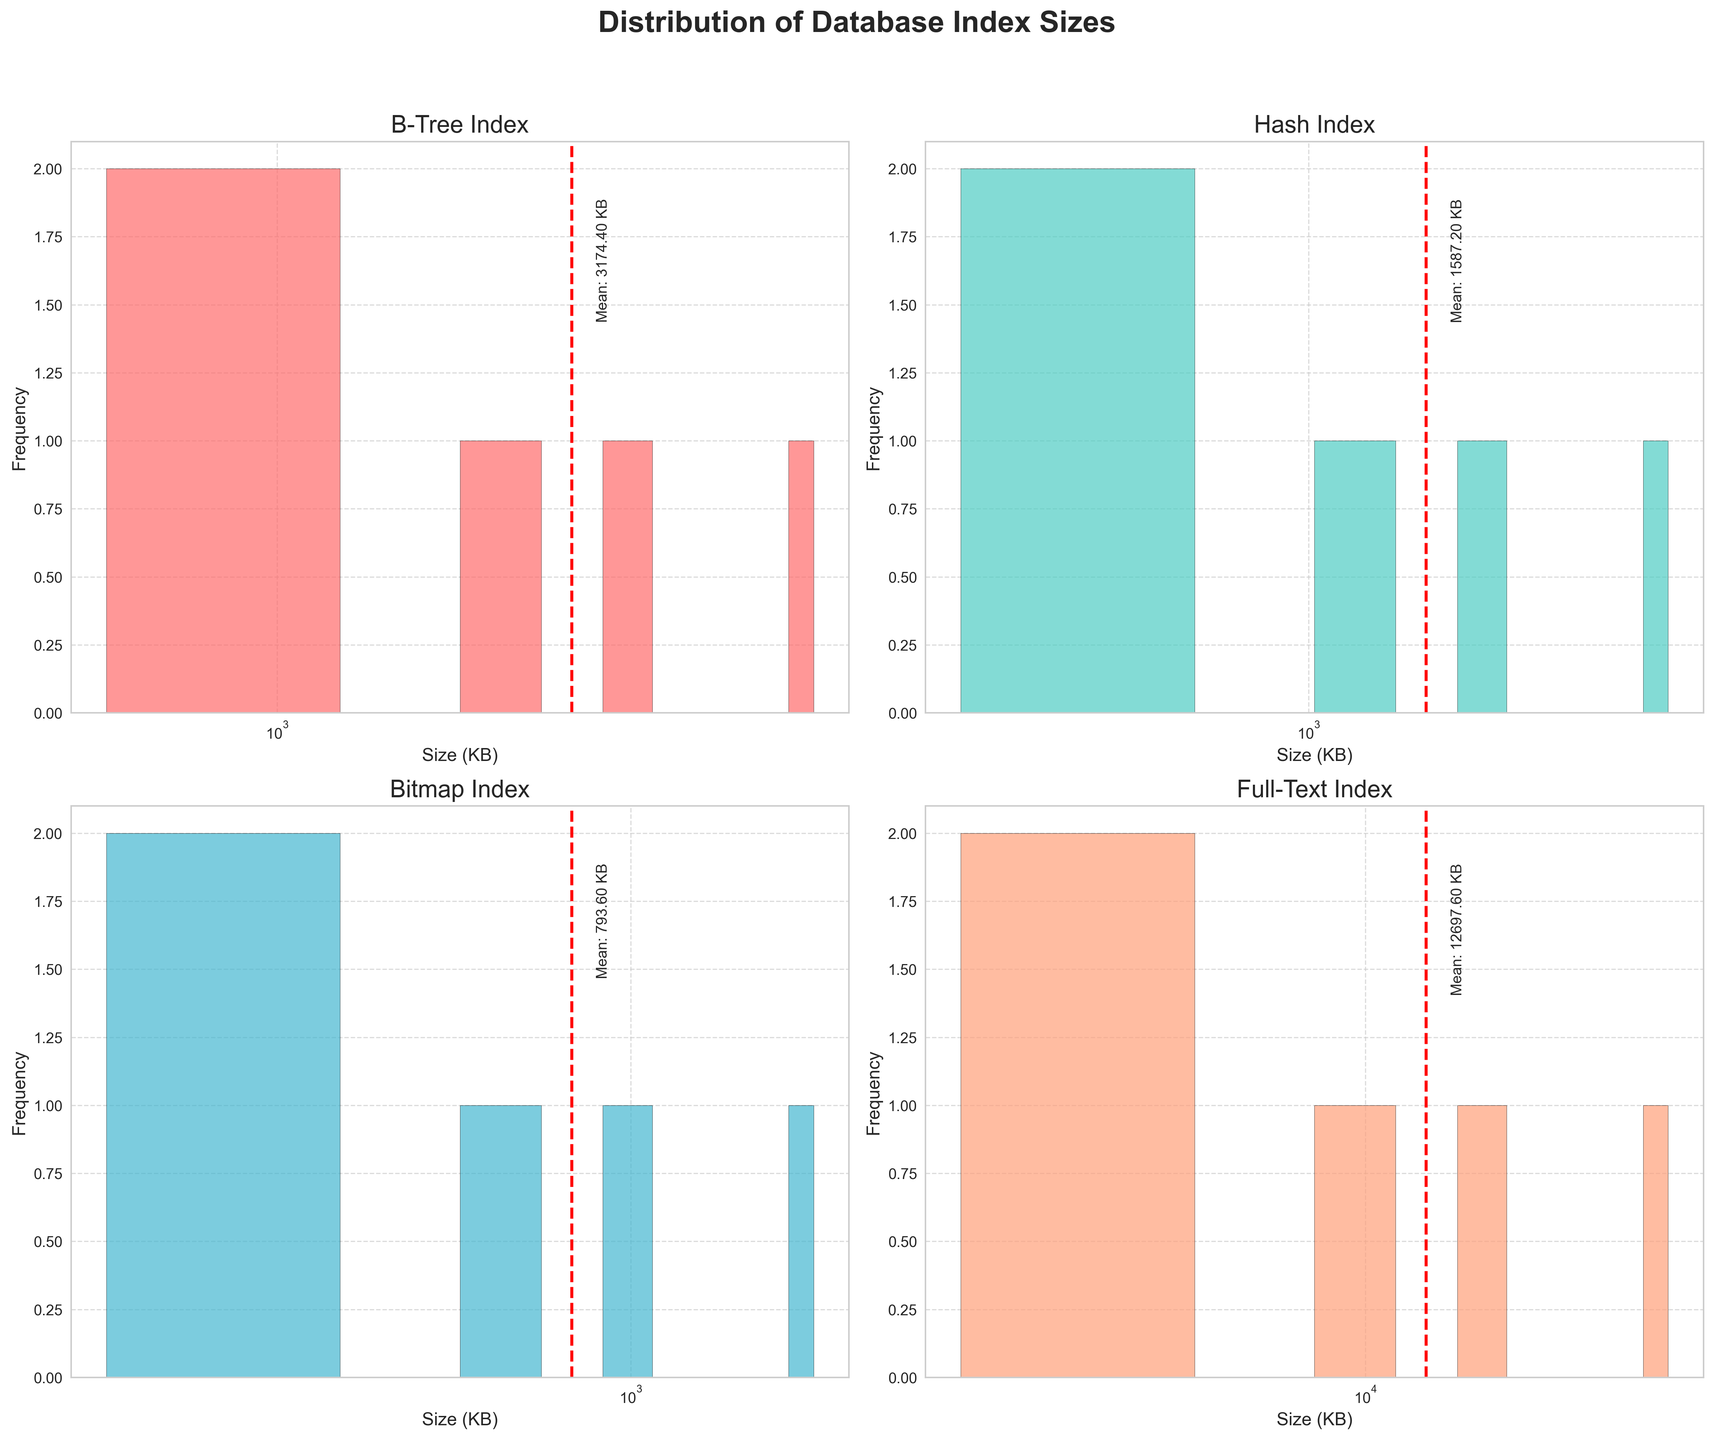What is the title of the figure? The title is found at the top of the figure and provides an overview of the visual data representation.
Answer: Distribution of Database Index Sizes What is the x-axis label for the B-Tree index subplot? The x-axis label indicates what the horizontal axis represents in the histogram. For the B-Tree index subplot, it should represent the size in KB.
Answer: Size (KB) What color is used for the Full-Text Index histogram? The color of the bars can be observed directly from the corresponding subplot. Each index type uses a distinct color. For the Full-Text index, locate its subplot and note the bar color.
Answer: Light salmon (close to #FFA07A) Which index type has the highest mean size, and what is that size? To find the highest mean, look at the red dashed lines in each subplot and their corresponding mean text. The Full-Text index has the highest mean size, which can be read from the red dashed line annotation.
Answer: Full-Text, 13,312 KB How does the frequency distribution of sizes compare between B-Tree and Bitmap indexes? Compare the shape and spread of the histograms for B-Tree and Bitmap indexes. Note that B-Tree has a wider spread of sizes, while Bitmap has smaller sizes concentrated on the left side.
Answer: B-Tree has a wider spread; Bitmap is more concentrated in smaller sizes Which index type has the smallest recorded size, and what is that size? Examine each subplot for the smallest left-most bar. The smallest size among all histograms is located in the Bitmap index subplot.
Answer: Bitmap, 128 KB Which index type has the most evenly distributed sizes across the histogram bins? Even distribution indicates that the bars in the histogram are relatively equal in height. The Orders database with Hash index shows a more even distribution compared to others.
Answer: Hash Is there any index type with a single dominant size? If so, which one and what is the dominant size? A dominant size will appear as a tall bar in one of the histograms. The Full-Text index for Articles has a dominant size at 32,768 KB.
Answer: Full-Text, 32,768 KB What is the mean size of the Bitmap index? Identify the red dashed line in the Bitmap subplot and the annotated mean size text. For the Bitmap index, the mean size is given by this annotation.
Answer: 792 KB 